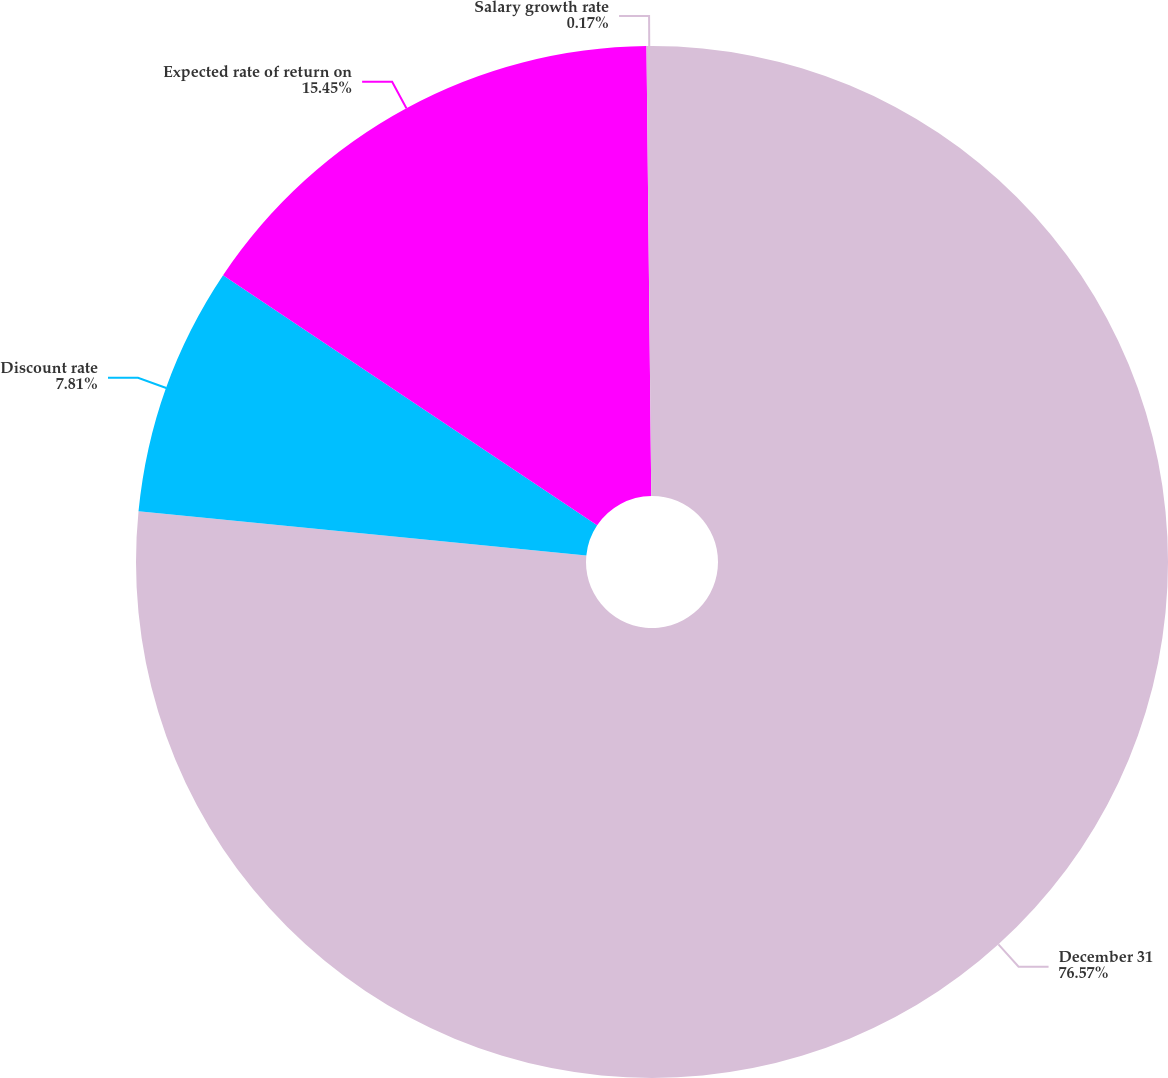<chart> <loc_0><loc_0><loc_500><loc_500><pie_chart><fcel>December 31<fcel>Discount rate<fcel>Expected rate of return on<fcel>Salary growth rate<nl><fcel>76.57%<fcel>7.81%<fcel>15.45%<fcel>0.17%<nl></chart> 